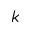<formula> <loc_0><loc_0><loc_500><loc_500>k</formula> 